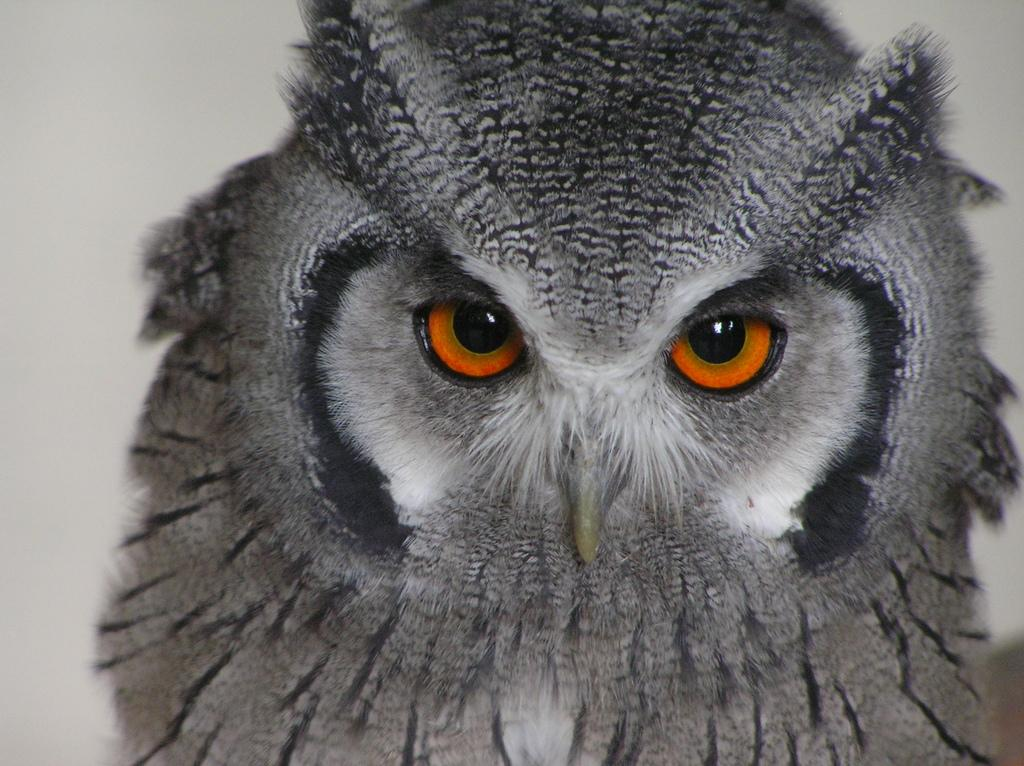What type of animal is in the image? There is an owl in the image. What type of cactus can be seen in the image? There is no cactus present in the image; it features an owl. What type of wax is being used by the owl in the image? There is no wax or any indication of its use in the image; it features an owl. 